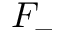<formula> <loc_0><loc_0><loc_500><loc_500>F _ { - }</formula> 